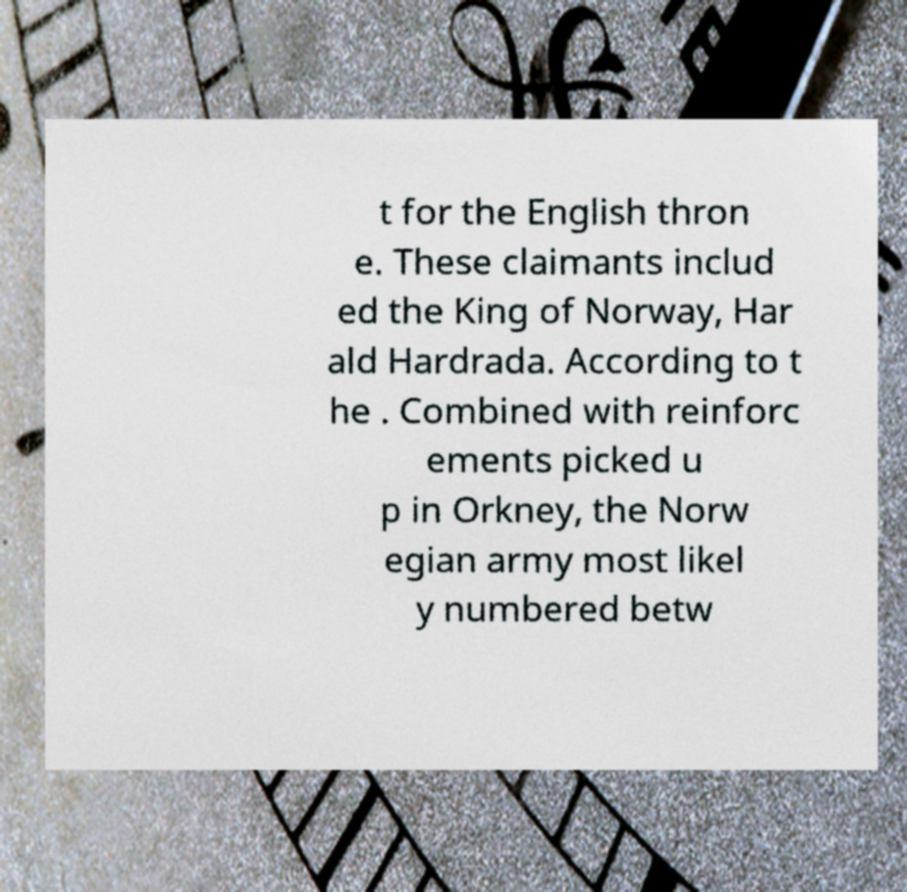Could you extract and type out the text from this image? t for the English thron e. These claimants includ ed the King of Norway, Har ald Hardrada. According to t he . Combined with reinforc ements picked u p in Orkney, the Norw egian army most likel y numbered betw 